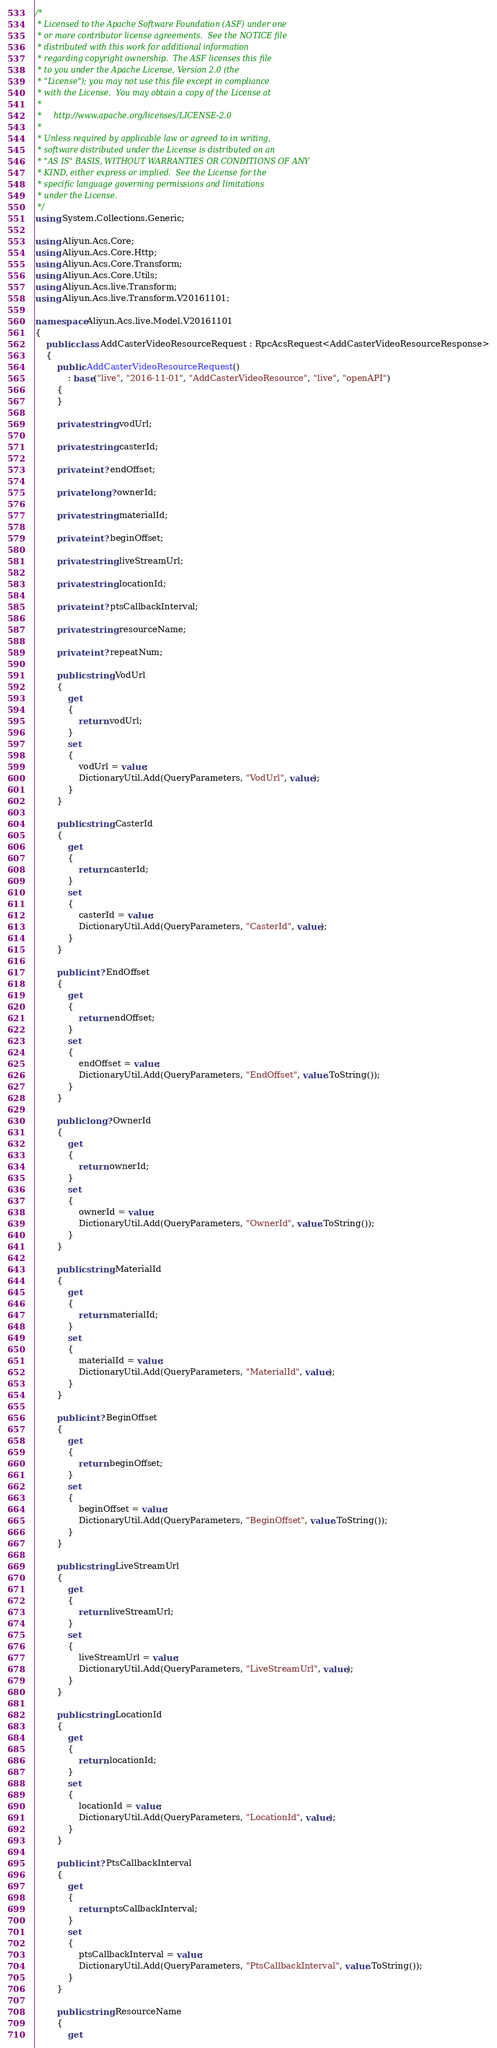<code> <loc_0><loc_0><loc_500><loc_500><_C#_>/*
 * Licensed to the Apache Software Foundation (ASF) under one
 * or more contributor license agreements.  See the NOTICE file
 * distributed with this work for additional information
 * regarding copyright ownership.  The ASF licenses this file
 * to you under the Apache License, Version 2.0 (the
 * "License"); you may not use this file except in compliance
 * with the License.  You may obtain a copy of the License at
 *
 *     http://www.apache.org/licenses/LICENSE-2.0
 *
 * Unless required by applicable law or agreed to in writing,
 * software distributed under the License is distributed on an
 * "AS IS" BASIS, WITHOUT WARRANTIES OR CONDITIONS OF ANY
 * KIND, either express or implied.  See the License for the
 * specific language governing permissions and limitations
 * under the License.
 */
using System.Collections.Generic;

using Aliyun.Acs.Core;
using Aliyun.Acs.Core.Http;
using Aliyun.Acs.Core.Transform;
using Aliyun.Acs.Core.Utils;
using Aliyun.Acs.live.Transform;
using Aliyun.Acs.live.Transform.V20161101;

namespace Aliyun.Acs.live.Model.V20161101
{
    public class AddCasterVideoResourceRequest : RpcAcsRequest<AddCasterVideoResourceResponse>
    {
        public AddCasterVideoResourceRequest()
            : base("live", "2016-11-01", "AddCasterVideoResource", "live", "openAPI")
        {
        }

		private string vodUrl;

		private string casterId;

		private int? endOffset;

		private long? ownerId;

		private string materialId;

		private int? beginOffset;

		private string liveStreamUrl;

		private string locationId;

		private int? ptsCallbackInterval;

		private string resourceName;

		private int? repeatNum;

		public string VodUrl
		{
			get
			{
				return vodUrl;
			}
			set	
			{
				vodUrl = value;
				DictionaryUtil.Add(QueryParameters, "VodUrl", value);
			}
		}

		public string CasterId
		{
			get
			{
				return casterId;
			}
			set	
			{
				casterId = value;
				DictionaryUtil.Add(QueryParameters, "CasterId", value);
			}
		}

		public int? EndOffset
		{
			get
			{
				return endOffset;
			}
			set	
			{
				endOffset = value;
				DictionaryUtil.Add(QueryParameters, "EndOffset", value.ToString());
			}
		}

		public long? OwnerId
		{
			get
			{
				return ownerId;
			}
			set	
			{
				ownerId = value;
				DictionaryUtil.Add(QueryParameters, "OwnerId", value.ToString());
			}
		}

		public string MaterialId
		{
			get
			{
				return materialId;
			}
			set	
			{
				materialId = value;
				DictionaryUtil.Add(QueryParameters, "MaterialId", value);
			}
		}

		public int? BeginOffset
		{
			get
			{
				return beginOffset;
			}
			set	
			{
				beginOffset = value;
				DictionaryUtil.Add(QueryParameters, "BeginOffset", value.ToString());
			}
		}

		public string LiveStreamUrl
		{
			get
			{
				return liveStreamUrl;
			}
			set	
			{
				liveStreamUrl = value;
				DictionaryUtil.Add(QueryParameters, "LiveStreamUrl", value);
			}
		}

		public string LocationId
		{
			get
			{
				return locationId;
			}
			set	
			{
				locationId = value;
				DictionaryUtil.Add(QueryParameters, "LocationId", value);
			}
		}

		public int? PtsCallbackInterval
		{
			get
			{
				return ptsCallbackInterval;
			}
			set	
			{
				ptsCallbackInterval = value;
				DictionaryUtil.Add(QueryParameters, "PtsCallbackInterval", value.ToString());
			}
		}

		public string ResourceName
		{
			get</code> 